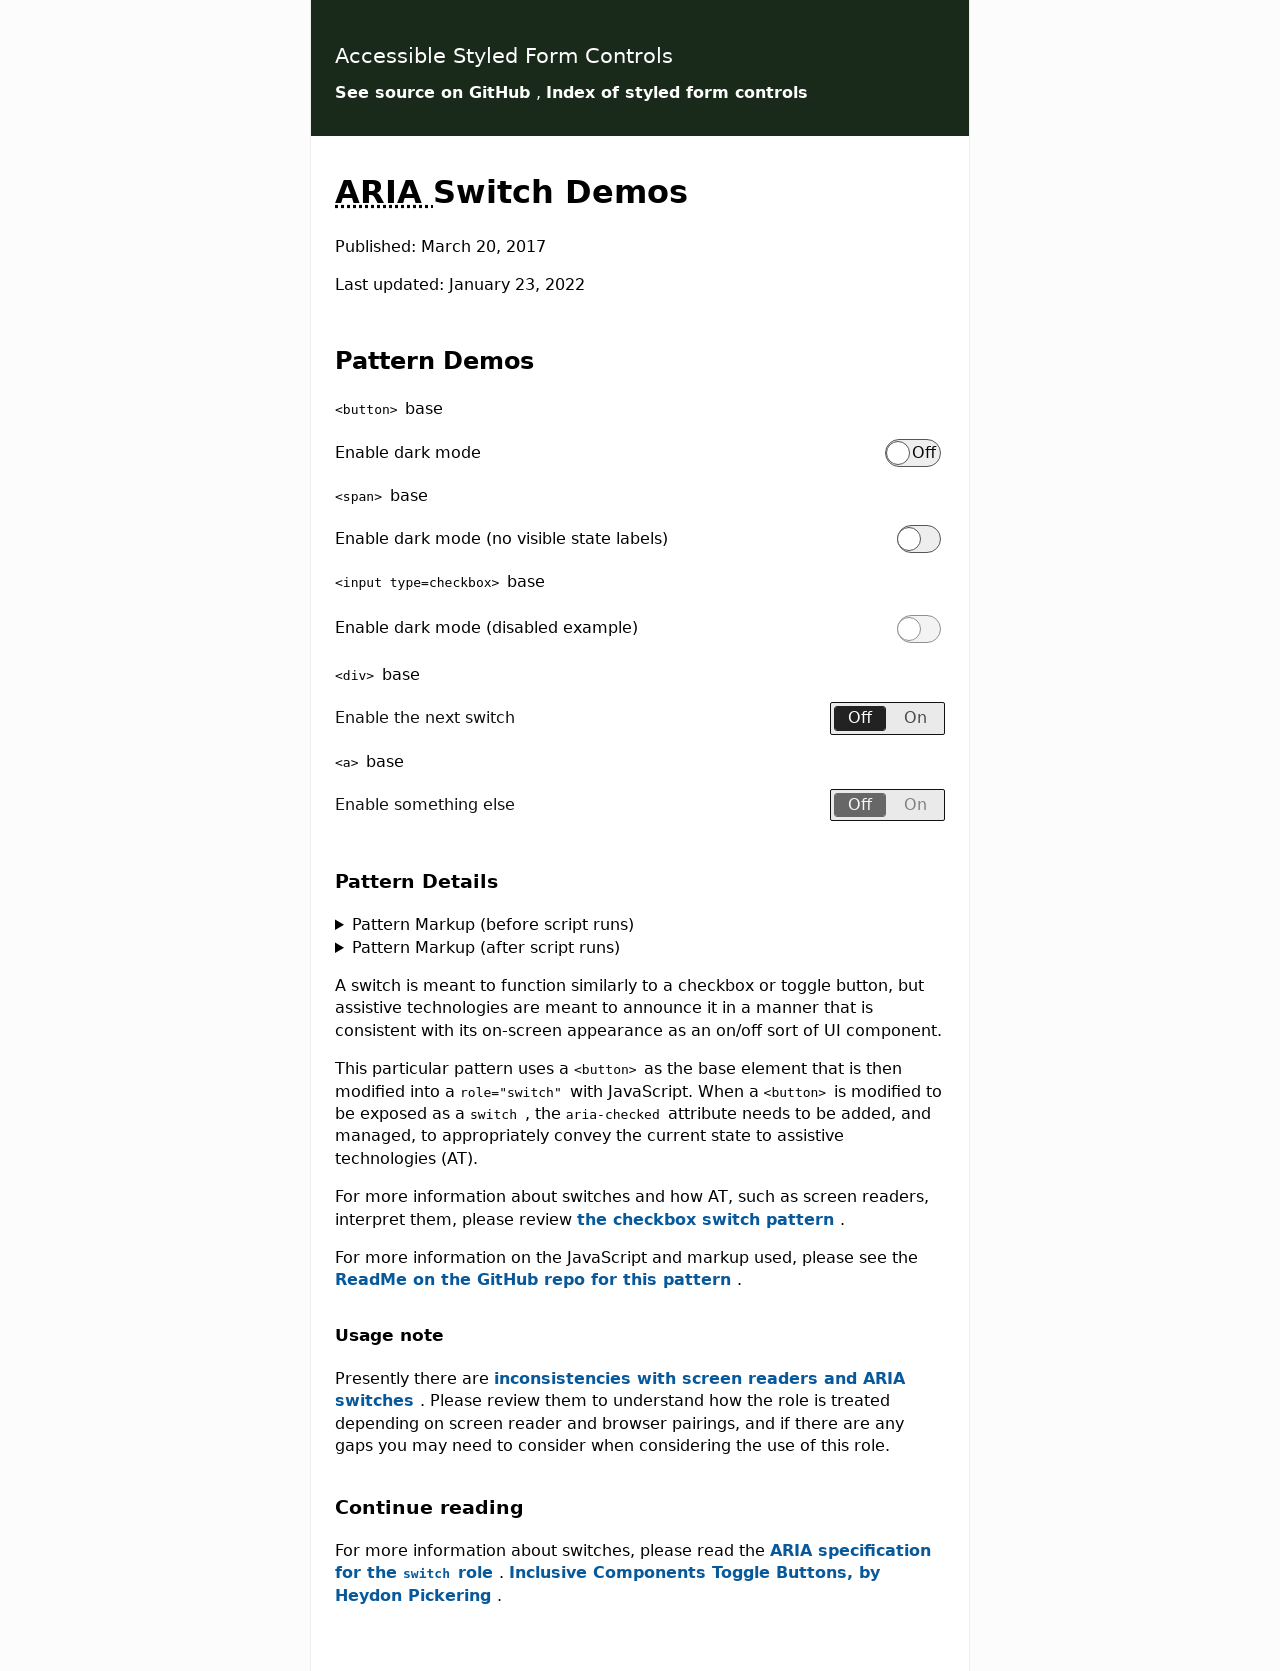What are some potential use cases for ARIA-switches shown in this website? The ARIA switches depicted can be used in a variety of applications to improve user interface accessibility. Potential use cases include light or dark mode toggles, settings activation or deactivation like turning on/off sound notifications, adjusting privacy settings, or any scenario where a binary choice is applicable. Their implementation enhances the user experience, particularly for those with accessibility requirements. 